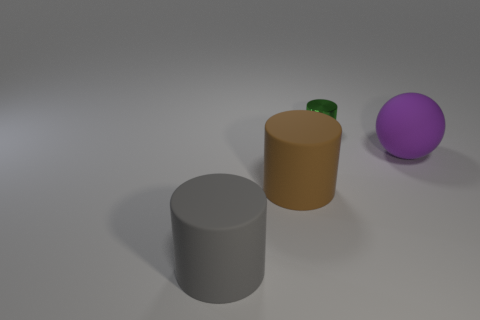Do the rubber thing that is right of the small green cylinder and the cylinder right of the brown object have the same size?
Make the answer very short. No. Is the number of spheres greater than the number of tiny blue objects?
Give a very brief answer. Yes. What number of small spheres are made of the same material as the brown thing?
Your answer should be very brief. 0. Is the brown thing the same shape as the green thing?
Your answer should be very brief. Yes. There is a rubber thing to the right of the cylinder that is behind the rubber thing that is to the right of the metallic object; how big is it?
Offer a terse response. Large. There is a object that is right of the green cylinder; is there a shiny cylinder in front of it?
Your answer should be very brief. No. What number of metal cylinders are behind the cylinder that is to the left of the big cylinder that is to the right of the large gray matte cylinder?
Give a very brief answer. 1. What is the color of the cylinder that is in front of the shiny cylinder and right of the gray rubber object?
Offer a very short reply. Brown. How many big matte cylinders are the same color as the ball?
Ensure brevity in your answer.  0. How many balls are either large purple objects or brown objects?
Your answer should be compact. 1. 